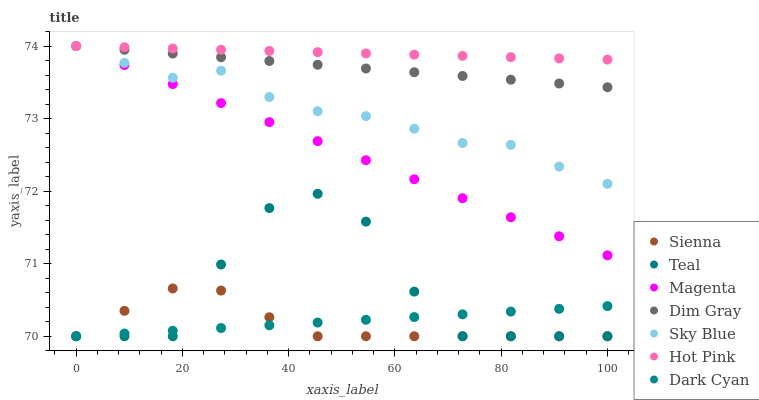Does Sienna have the minimum area under the curve?
Answer yes or no. Yes. Does Hot Pink have the maximum area under the curve?
Answer yes or no. Yes. Does Hot Pink have the minimum area under the curve?
Answer yes or no. No. Does Sienna have the maximum area under the curve?
Answer yes or no. No. Is Hot Pink the smoothest?
Answer yes or no. Yes. Is Teal the roughest?
Answer yes or no. Yes. Is Sienna the smoothest?
Answer yes or no. No. Is Sienna the roughest?
Answer yes or no. No. Does Sienna have the lowest value?
Answer yes or no. Yes. Does Hot Pink have the lowest value?
Answer yes or no. No. Does Magenta have the highest value?
Answer yes or no. Yes. Does Sienna have the highest value?
Answer yes or no. No. Is Sienna less than Hot Pink?
Answer yes or no. Yes. Is Magenta greater than Sienna?
Answer yes or no. Yes. Does Sky Blue intersect Dim Gray?
Answer yes or no. Yes. Is Sky Blue less than Dim Gray?
Answer yes or no. No. Is Sky Blue greater than Dim Gray?
Answer yes or no. No. Does Sienna intersect Hot Pink?
Answer yes or no. No. 